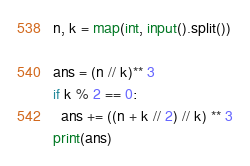Convert code to text. <code><loc_0><loc_0><loc_500><loc_500><_Python_>n, k = map(int, input().split())

ans = (n // k)** 3
if k % 2 == 0:
  ans += ((n + k // 2) // k) ** 3
print(ans)</code> 